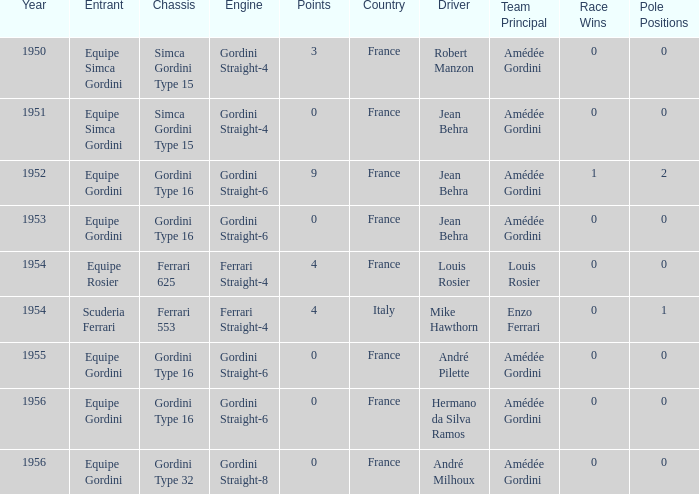What engine was used by Equipe Simca Gordini before 1956 with less than 4 points? Gordini Straight-4, Gordini Straight-4. 